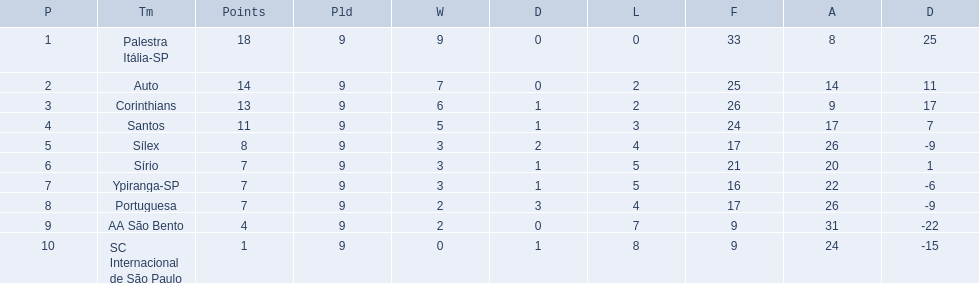What teams played in 1926? Palestra Itália-SP, Auto, Corinthians, Santos, Sílex, Sírio, Ypiranga-SP, Portuguesa, AA São Bento, SC Internacional de São Paulo. Did any team lose zero games? Palestra Itália-SP. 